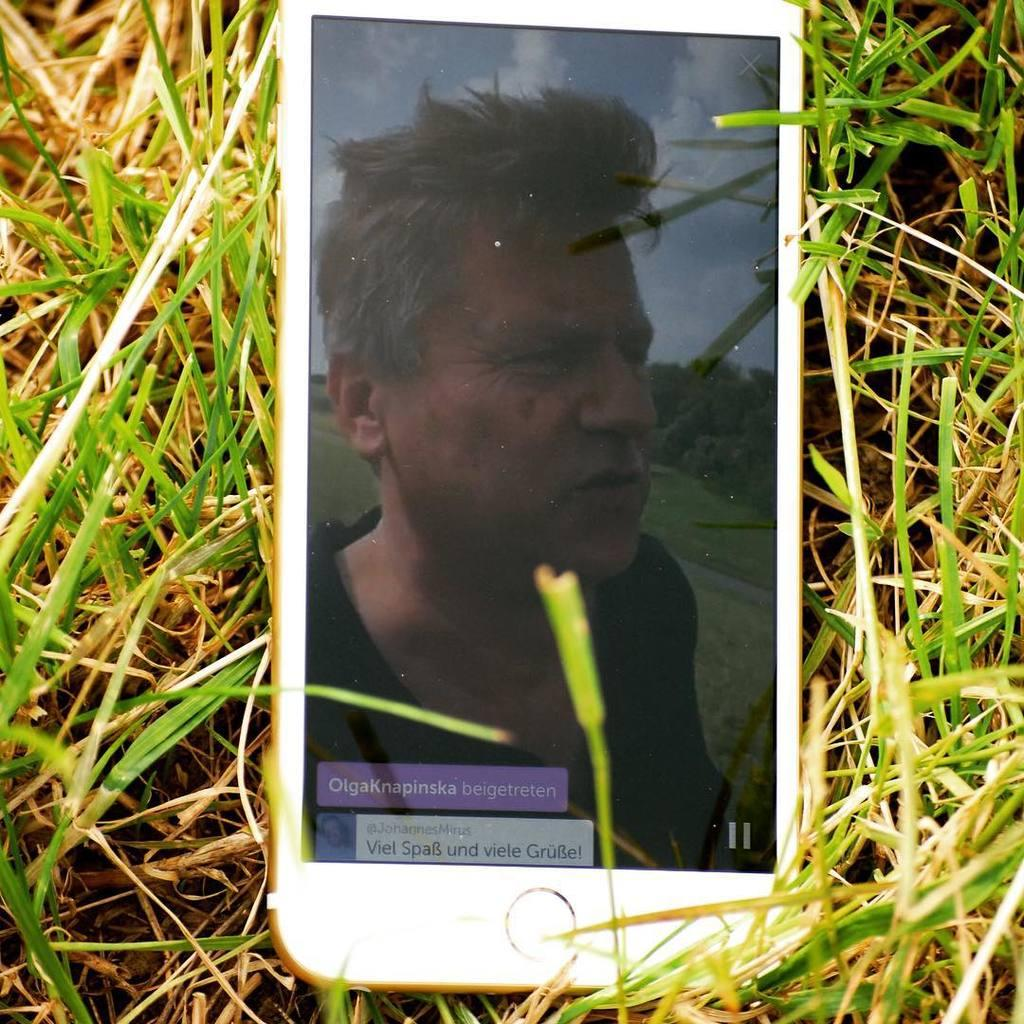What electronic device is visible in the image? There is a mobile phone in the image. What is being displayed on the mobile phone? The mobile phone is displaying something. Where is the mobile phone located in the image? The mobile phone is placed on the grass. What type of crook is visible in the image? There is no crook present in the image. How does the base of the mobile phone help it function in the image? The image does not show a base for the mobile phone, as it is placed on the grass. 